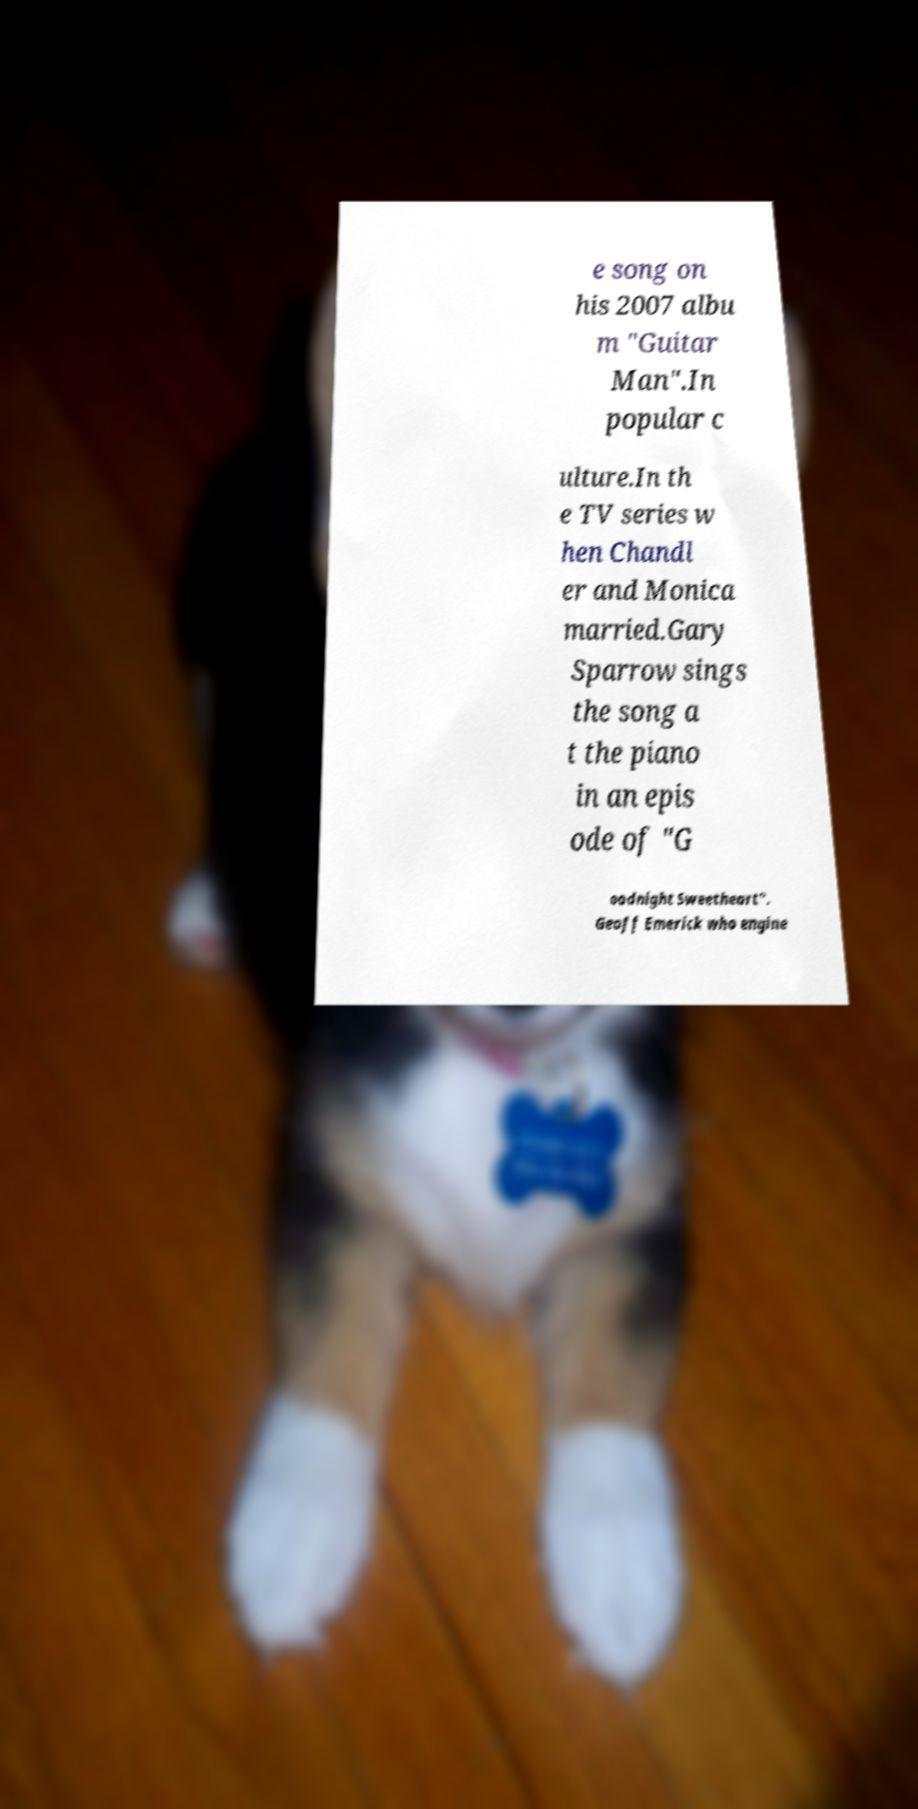Can you read and provide the text displayed in the image?This photo seems to have some interesting text. Can you extract and type it out for me? e song on his 2007 albu m "Guitar Man".In popular c ulture.In th e TV series w hen Chandl er and Monica married.Gary Sparrow sings the song a t the piano in an epis ode of "G oodnight Sweetheart". Geoff Emerick who engine 